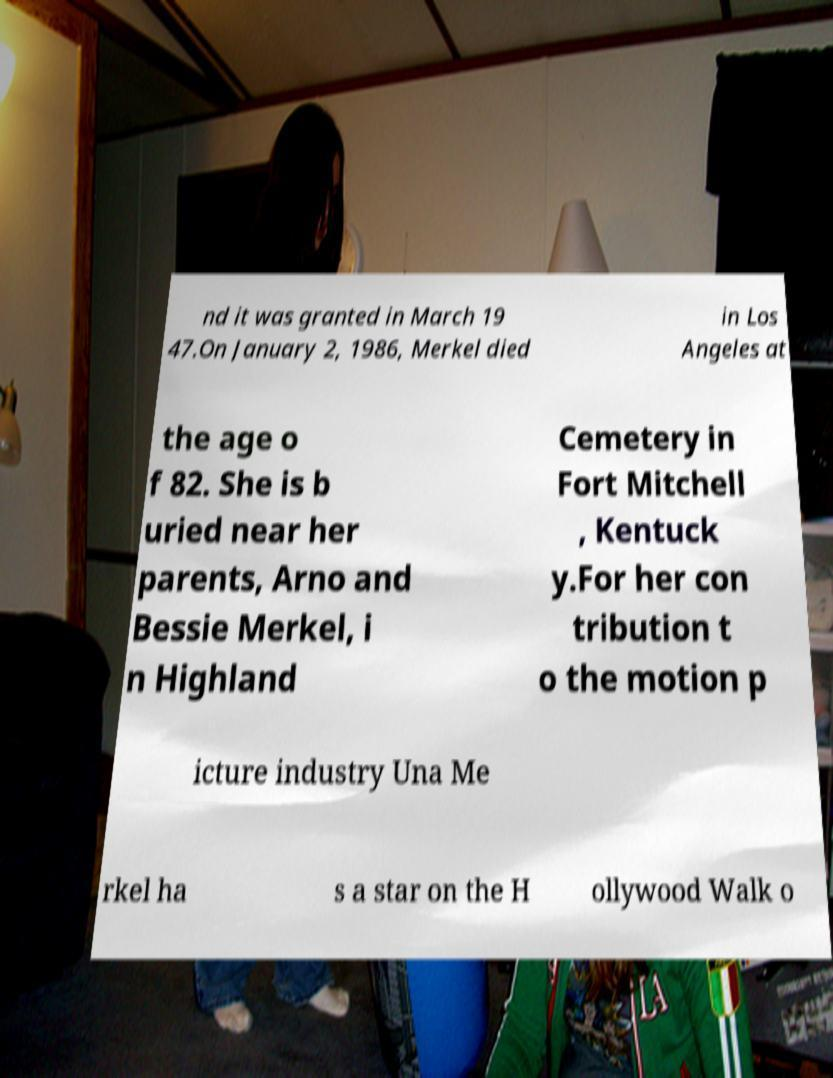What messages or text are displayed in this image? I need them in a readable, typed format. nd it was granted in March 19 47.On January 2, 1986, Merkel died in Los Angeles at the age o f 82. She is b uried near her parents, Arno and Bessie Merkel, i n Highland Cemetery in Fort Mitchell , Kentuck y.For her con tribution t o the motion p icture industry Una Me rkel ha s a star on the H ollywood Walk o 